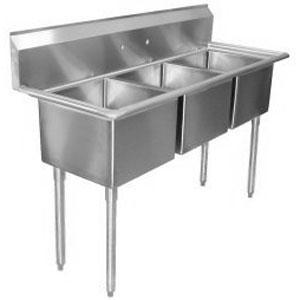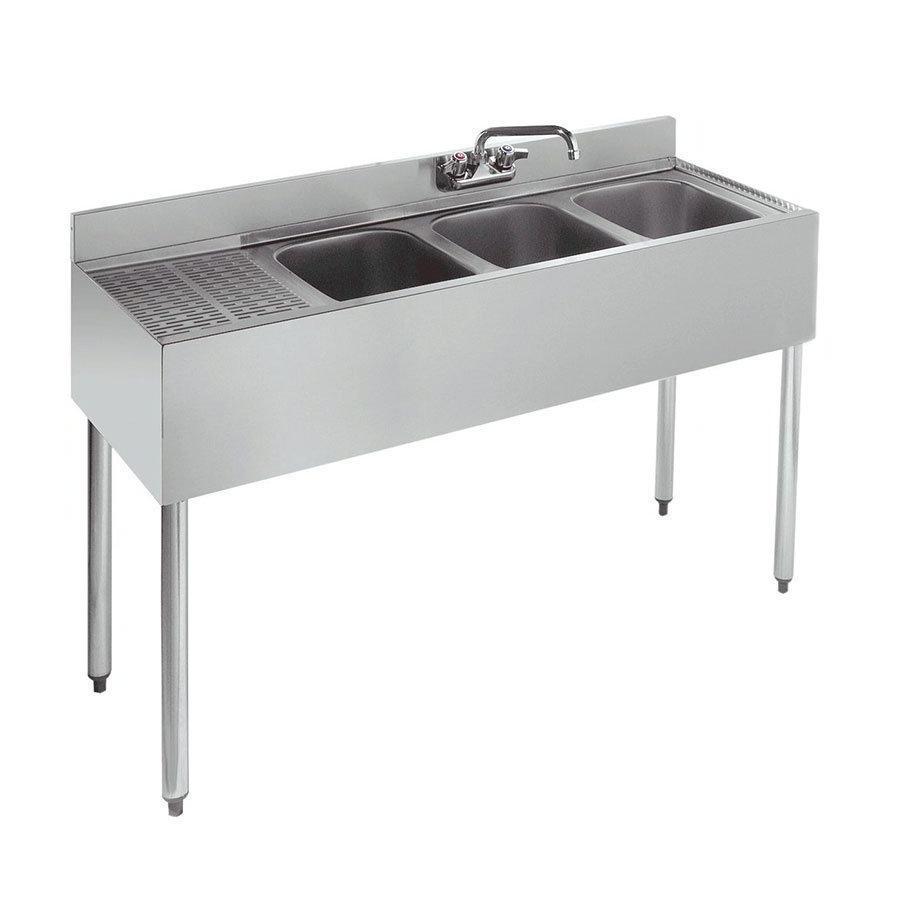The first image is the image on the left, the second image is the image on the right. Considering the images on both sides, is "Two silvery metal prep sinks stand on legs, and each has two or more sink bowls." valid? Answer yes or no. Yes. 